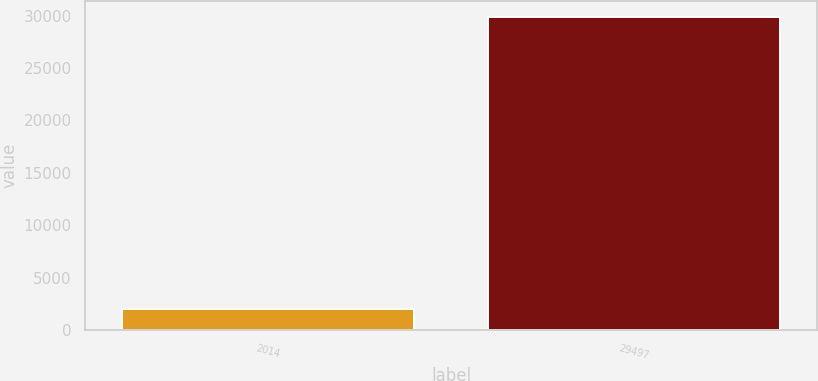Convert chart. <chart><loc_0><loc_0><loc_500><loc_500><bar_chart><fcel>2014<fcel>29497<nl><fcel>2013<fcel>29905<nl></chart> 